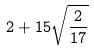<formula> <loc_0><loc_0><loc_500><loc_500>2 + 1 5 \sqrt { \frac { 2 } { 1 7 } }</formula> 